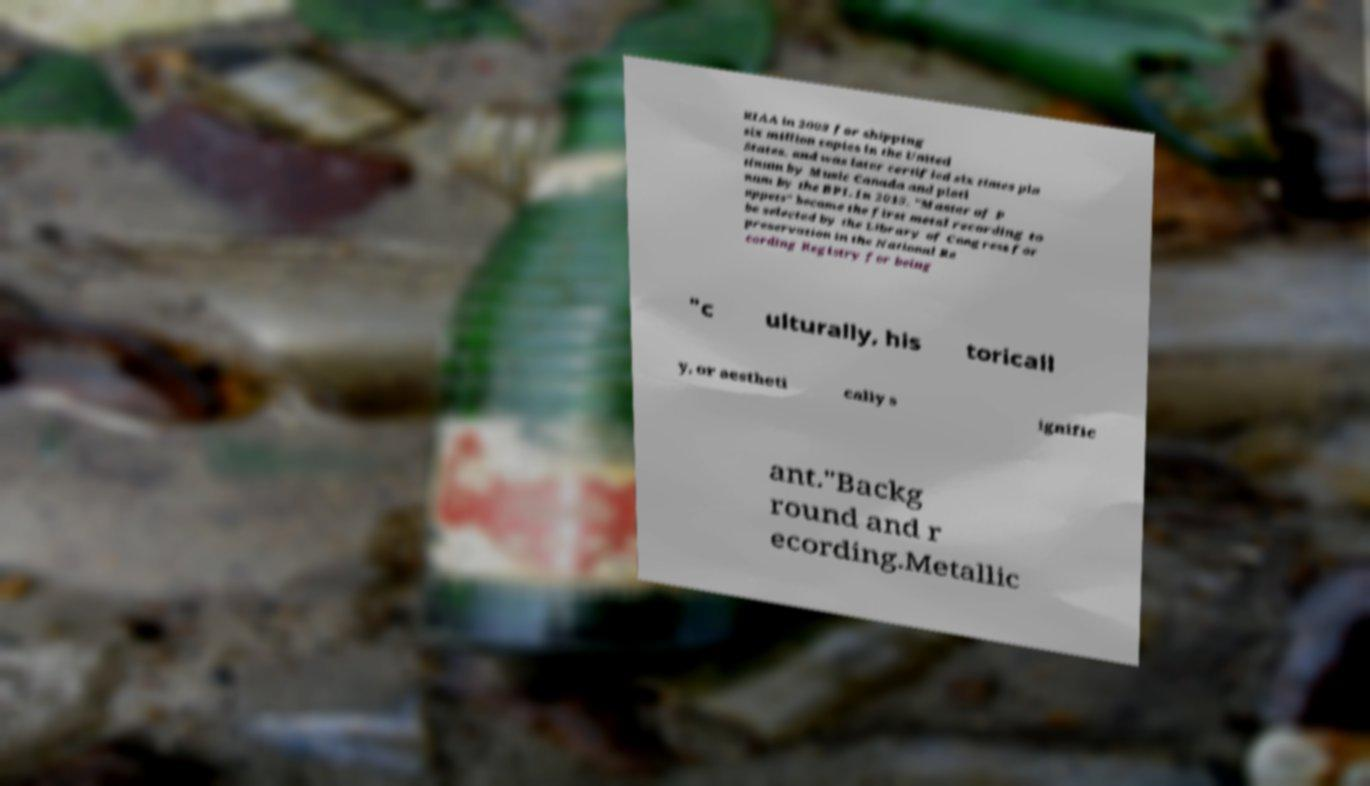Please identify and transcribe the text found in this image. RIAA in 2003 for shipping six million copies in the United States, and was later certified six times pla tinum by Music Canada and plati num by the BPI. In 2015, "Master of P uppets" became the first metal recording to be selected by the Library of Congress for preservation in the National Re cording Registry for being "c ulturally, his toricall y, or aestheti cally s ignific ant."Backg round and r ecording.Metallic 